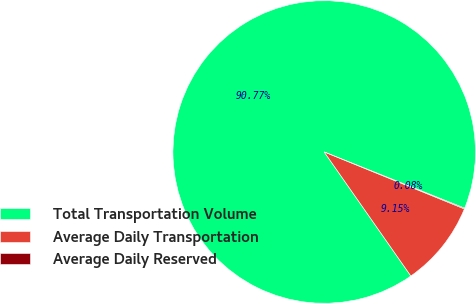<chart> <loc_0><loc_0><loc_500><loc_500><pie_chart><fcel>Total Transportation Volume<fcel>Average Daily Transportation<fcel>Average Daily Reserved<nl><fcel>90.77%<fcel>9.15%<fcel>0.08%<nl></chart> 